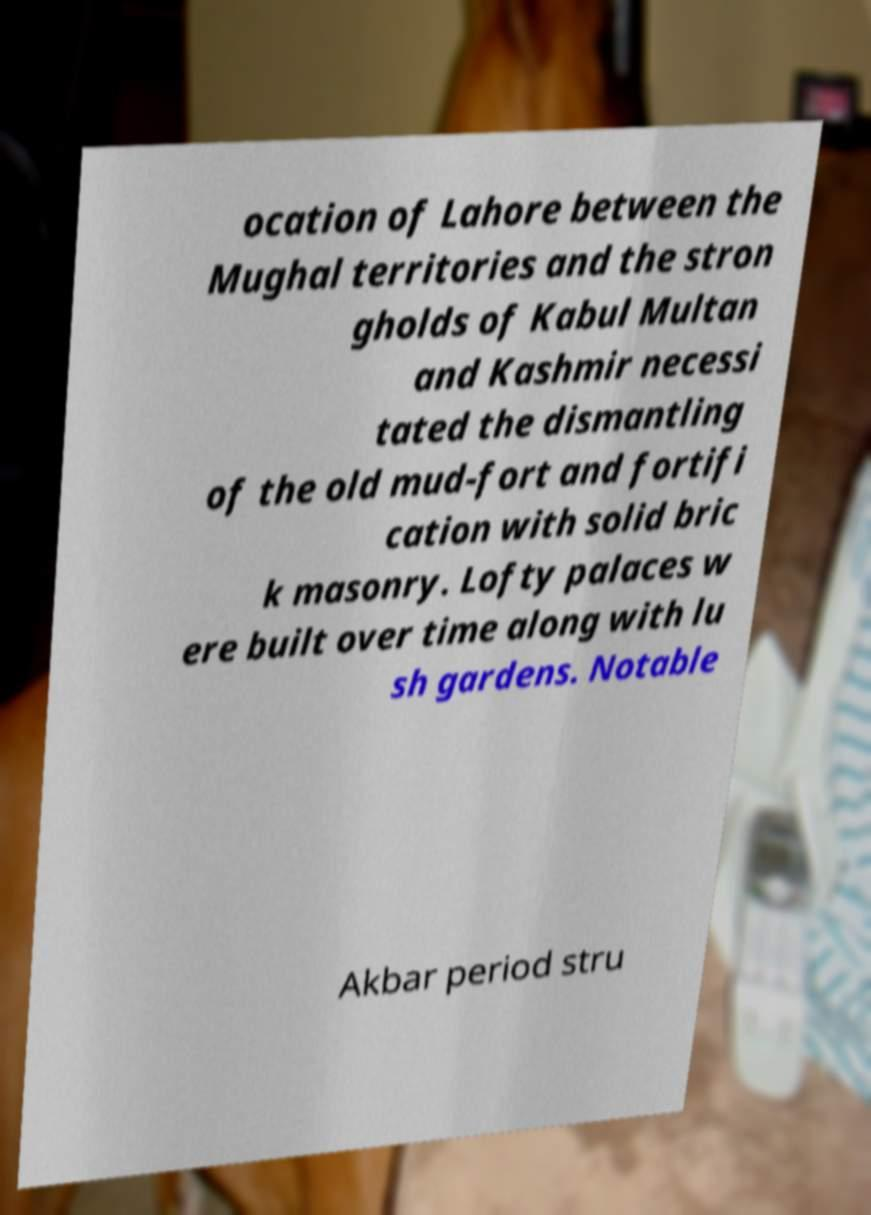Can you accurately transcribe the text from the provided image for me? ocation of Lahore between the Mughal territories and the stron gholds of Kabul Multan and Kashmir necessi tated the dismantling of the old mud-fort and fortifi cation with solid bric k masonry. Lofty palaces w ere built over time along with lu sh gardens. Notable Akbar period stru 